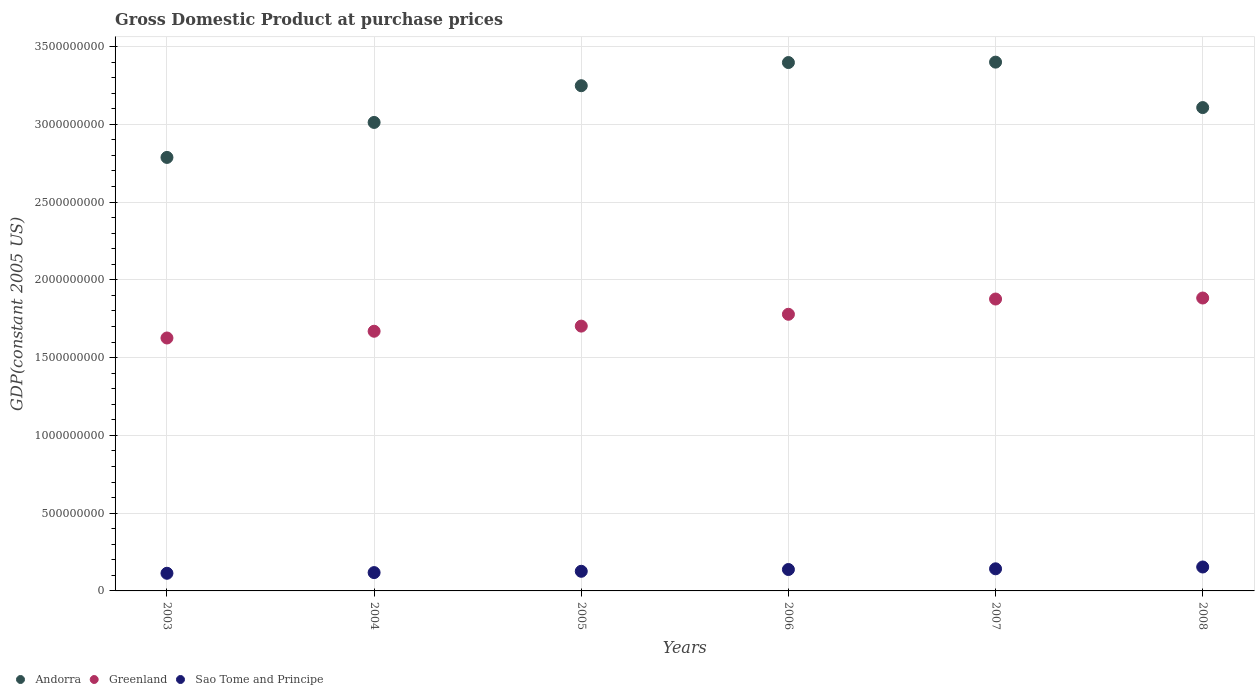How many different coloured dotlines are there?
Make the answer very short. 3. What is the GDP at purchase prices in Greenland in 2006?
Your answer should be compact. 1.78e+09. Across all years, what is the maximum GDP at purchase prices in Greenland?
Make the answer very short. 1.88e+09. Across all years, what is the minimum GDP at purchase prices in Andorra?
Keep it short and to the point. 2.79e+09. In which year was the GDP at purchase prices in Andorra maximum?
Your answer should be compact. 2007. In which year was the GDP at purchase prices in Andorra minimum?
Provide a short and direct response. 2003. What is the total GDP at purchase prices in Greenland in the graph?
Provide a short and direct response. 1.05e+1. What is the difference between the GDP at purchase prices in Greenland in 2003 and that in 2004?
Keep it short and to the point. -4.34e+07. What is the difference between the GDP at purchase prices in Greenland in 2005 and the GDP at purchase prices in Sao Tome and Principe in 2007?
Provide a succinct answer. 1.56e+09. What is the average GDP at purchase prices in Sao Tome and Principe per year?
Your answer should be very brief. 1.32e+08. In the year 2008, what is the difference between the GDP at purchase prices in Greenland and GDP at purchase prices in Sao Tome and Principe?
Give a very brief answer. 1.73e+09. In how many years, is the GDP at purchase prices in Sao Tome and Principe greater than 1000000000 US$?
Ensure brevity in your answer.  0. What is the ratio of the GDP at purchase prices in Greenland in 2006 to that in 2007?
Provide a short and direct response. 0.95. Is the GDP at purchase prices in Sao Tome and Principe in 2004 less than that in 2006?
Your answer should be compact. Yes. Is the difference between the GDP at purchase prices in Greenland in 2004 and 2008 greater than the difference between the GDP at purchase prices in Sao Tome and Principe in 2004 and 2008?
Keep it short and to the point. No. What is the difference between the highest and the second highest GDP at purchase prices in Sao Tome and Principe?
Your answer should be very brief. 1.16e+07. What is the difference between the highest and the lowest GDP at purchase prices in Greenland?
Offer a terse response. 2.57e+08. In how many years, is the GDP at purchase prices in Greenland greater than the average GDP at purchase prices in Greenland taken over all years?
Provide a short and direct response. 3. Is it the case that in every year, the sum of the GDP at purchase prices in Sao Tome and Principe and GDP at purchase prices in Greenland  is greater than the GDP at purchase prices in Andorra?
Your response must be concise. No. How many dotlines are there?
Make the answer very short. 3. How many years are there in the graph?
Your answer should be compact. 6. Are the values on the major ticks of Y-axis written in scientific E-notation?
Make the answer very short. No. Does the graph contain grids?
Provide a short and direct response. Yes. Where does the legend appear in the graph?
Provide a succinct answer. Bottom left. How many legend labels are there?
Make the answer very short. 3. How are the legend labels stacked?
Provide a short and direct response. Horizontal. What is the title of the graph?
Make the answer very short. Gross Domestic Product at purchase prices. Does "Malta" appear as one of the legend labels in the graph?
Offer a very short reply. No. What is the label or title of the Y-axis?
Your answer should be very brief. GDP(constant 2005 US). What is the GDP(constant 2005 US) in Andorra in 2003?
Keep it short and to the point. 2.79e+09. What is the GDP(constant 2005 US) of Greenland in 2003?
Offer a terse response. 1.63e+09. What is the GDP(constant 2005 US) in Sao Tome and Principe in 2003?
Your answer should be compact. 1.13e+08. What is the GDP(constant 2005 US) of Andorra in 2004?
Make the answer very short. 3.01e+09. What is the GDP(constant 2005 US) of Greenland in 2004?
Make the answer very short. 1.67e+09. What is the GDP(constant 2005 US) in Sao Tome and Principe in 2004?
Your answer should be compact. 1.18e+08. What is the GDP(constant 2005 US) in Andorra in 2005?
Keep it short and to the point. 3.25e+09. What is the GDP(constant 2005 US) in Greenland in 2005?
Give a very brief answer. 1.70e+09. What is the GDP(constant 2005 US) in Sao Tome and Principe in 2005?
Keep it short and to the point. 1.26e+08. What is the GDP(constant 2005 US) in Andorra in 2006?
Make the answer very short. 3.40e+09. What is the GDP(constant 2005 US) in Greenland in 2006?
Your response must be concise. 1.78e+09. What is the GDP(constant 2005 US) of Sao Tome and Principe in 2006?
Provide a succinct answer. 1.38e+08. What is the GDP(constant 2005 US) of Andorra in 2007?
Offer a very short reply. 3.40e+09. What is the GDP(constant 2005 US) in Greenland in 2007?
Make the answer very short. 1.88e+09. What is the GDP(constant 2005 US) of Sao Tome and Principe in 2007?
Offer a very short reply. 1.42e+08. What is the GDP(constant 2005 US) of Andorra in 2008?
Offer a very short reply. 3.11e+09. What is the GDP(constant 2005 US) of Greenland in 2008?
Make the answer very short. 1.88e+09. What is the GDP(constant 2005 US) of Sao Tome and Principe in 2008?
Keep it short and to the point. 1.54e+08. Across all years, what is the maximum GDP(constant 2005 US) in Andorra?
Your answer should be very brief. 3.40e+09. Across all years, what is the maximum GDP(constant 2005 US) of Greenland?
Your answer should be very brief. 1.88e+09. Across all years, what is the maximum GDP(constant 2005 US) in Sao Tome and Principe?
Your response must be concise. 1.54e+08. Across all years, what is the minimum GDP(constant 2005 US) in Andorra?
Your response must be concise. 2.79e+09. Across all years, what is the minimum GDP(constant 2005 US) of Greenland?
Offer a very short reply. 1.63e+09. Across all years, what is the minimum GDP(constant 2005 US) of Sao Tome and Principe?
Keep it short and to the point. 1.13e+08. What is the total GDP(constant 2005 US) of Andorra in the graph?
Provide a short and direct response. 1.90e+1. What is the total GDP(constant 2005 US) of Greenland in the graph?
Offer a terse response. 1.05e+1. What is the total GDP(constant 2005 US) of Sao Tome and Principe in the graph?
Keep it short and to the point. 7.91e+08. What is the difference between the GDP(constant 2005 US) in Andorra in 2003 and that in 2004?
Your response must be concise. -2.25e+08. What is the difference between the GDP(constant 2005 US) of Greenland in 2003 and that in 2004?
Offer a terse response. -4.34e+07. What is the difference between the GDP(constant 2005 US) of Sao Tome and Principe in 2003 and that in 2004?
Ensure brevity in your answer.  -4.35e+06. What is the difference between the GDP(constant 2005 US) of Andorra in 2003 and that in 2005?
Keep it short and to the point. -4.61e+08. What is the difference between the GDP(constant 2005 US) in Greenland in 2003 and that in 2005?
Your response must be concise. -7.64e+07. What is the difference between the GDP(constant 2005 US) in Sao Tome and Principe in 2003 and that in 2005?
Offer a terse response. -1.27e+07. What is the difference between the GDP(constant 2005 US) of Andorra in 2003 and that in 2006?
Offer a terse response. -6.10e+08. What is the difference between the GDP(constant 2005 US) in Greenland in 2003 and that in 2006?
Your response must be concise. -1.53e+08. What is the difference between the GDP(constant 2005 US) of Sao Tome and Principe in 2003 and that in 2006?
Ensure brevity in your answer.  -2.42e+07. What is the difference between the GDP(constant 2005 US) in Andorra in 2003 and that in 2007?
Your answer should be very brief. -6.13e+08. What is the difference between the GDP(constant 2005 US) in Greenland in 2003 and that in 2007?
Give a very brief answer. -2.51e+08. What is the difference between the GDP(constant 2005 US) of Sao Tome and Principe in 2003 and that in 2007?
Make the answer very short. -2.87e+07. What is the difference between the GDP(constant 2005 US) of Andorra in 2003 and that in 2008?
Your answer should be very brief. -3.20e+08. What is the difference between the GDP(constant 2005 US) of Greenland in 2003 and that in 2008?
Give a very brief answer. -2.57e+08. What is the difference between the GDP(constant 2005 US) of Sao Tome and Principe in 2003 and that in 2008?
Provide a succinct answer. -4.03e+07. What is the difference between the GDP(constant 2005 US) of Andorra in 2004 and that in 2005?
Make the answer very short. -2.36e+08. What is the difference between the GDP(constant 2005 US) of Greenland in 2004 and that in 2005?
Offer a terse response. -3.30e+07. What is the difference between the GDP(constant 2005 US) in Sao Tome and Principe in 2004 and that in 2005?
Provide a short and direct response. -8.36e+06. What is the difference between the GDP(constant 2005 US) in Andorra in 2004 and that in 2006?
Your answer should be compact. -3.85e+08. What is the difference between the GDP(constant 2005 US) of Greenland in 2004 and that in 2006?
Your response must be concise. -1.09e+08. What is the difference between the GDP(constant 2005 US) of Sao Tome and Principe in 2004 and that in 2006?
Keep it short and to the point. -1.99e+07. What is the difference between the GDP(constant 2005 US) of Andorra in 2004 and that in 2007?
Keep it short and to the point. -3.88e+08. What is the difference between the GDP(constant 2005 US) in Greenland in 2004 and that in 2007?
Provide a succinct answer. -2.07e+08. What is the difference between the GDP(constant 2005 US) of Sao Tome and Principe in 2004 and that in 2007?
Your answer should be compact. -2.43e+07. What is the difference between the GDP(constant 2005 US) in Andorra in 2004 and that in 2008?
Provide a succinct answer. -9.55e+07. What is the difference between the GDP(constant 2005 US) in Greenland in 2004 and that in 2008?
Ensure brevity in your answer.  -2.14e+08. What is the difference between the GDP(constant 2005 US) of Sao Tome and Principe in 2004 and that in 2008?
Offer a terse response. -3.60e+07. What is the difference between the GDP(constant 2005 US) of Andorra in 2005 and that in 2006?
Keep it short and to the point. -1.49e+08. What is the difference between the GDP(constant 2005 US) of Greenland in 2005 and that in 2006?
Offer a terse response. -7.61e+07. What is the difference between the GDP(constant 2005 US) in Sao Tome and Principe in 2005 and that in 2006?
Provide a succinct answer. -1.15e+07. What is the difference between the GDP(constant 2005 US) in Andorra in 2005 and that in 2007?
Provide a short and direct response. -1.52e+08. What is the difference between the GDP(constant 2005 US) of Greenland in 2005 and that in 2007?
Your response must be concise. -1.74e+08. What is the difference between the GDP(constant 2005 US) in Sao Tome and Principe in 2005 and that in 2007?
Your response must be concise. -1.60e+07. What is the difference between the GDP(constant 2005 US) in Andorra in 2005 and that in 2008?
Make the answer very short. 1.41e+08. What is the difference between the GDP(constant 2005 US) in Greenland in 2005 and that in 2008?
Your answer should be very brief. -1.81e+08. What is the difference between the GDP(constant 2005 US) of Sao Tome and Principe in 2005 and that in 2008?
Your answer should be compact. -2.76e+07. What is the difference between the GDP(constant 2005 US) of Andorra in 2006 and that in 2007?
Provide a short and direct response. -2.65e+06. What is the difference between the GDP(constant 2005 US) of Greenland in 2006 and that in 2007?
Give a very brief answer. -9.81e+07. What is the difference between the GDP(constant 2005 US) of Sao Tome and Principe in 2006 and that in 2007?
Offer a terse response. -4.48e+06. What is the difference between the GDP(constant 2005 US) in Andorra in 2006 and that in 2008?
Your answer should be very brief. 2.90e+08. What is the difference between the GDP(constant 2005 US) of Greenland in 2006 and that in 2008?
Offer a terse response. -1.05e+08. What is the difference between the GDP(constant 2005 US) of Sao Tome and Principe in 2006 and that in 2008?
Make the answer very short. -1.61e+07. What is the difference between the GDP(constant 2005 US) of Andorra in 2007 and that in 2008?
Provide a succinct answer. 2.92e+08. What is the difference between the GDP(constant 2005 US) in Greenland in 2007 and that in 2008?
Your answer should be compact. -6.49e+06. What is the difference between the GDP(constant 2005 US) of Sao Tome and Principe in 2007 and that in 2008?
Make the answer very short. -1.16e+07. What is the difference between the GDP(constant 2005 US) of Andorra in 2003 and the GDP(constant 2005 US) of Greenland in 2004?
Your answer should be compact. 1.12e+09. What is the difference between the GDP(constant 2005 US) of Andorra in 2003 and the GDP(constant 2005 US) of Sao Tome and Principe in 2004?
Ensure brevity in your answer.  2.67e+09. What is the difference between the GDP(constant 2005 US) in Greenland in 2003 and the GDP(constant 2005 US) in Sao Tome and Principe in 2004?
Provide a succinct answer. 1.51e+09. What is the difference between the GDP(constant 2005 US) of Andorra in 2003 and the GDP(constant 2005 US) of Greenland in 2005?
Provide a succinct answer. 1.08e+09. What is the difference between the GDP(constant 2005 US) of Andorra in 2003 and the GDP(constant 2005 US) of Sao Tome and Principe in 2005?
Offer a very short reply. 2.66e+09. What is the difference between the GDP(constant 2005 US) of Greenland in 2003 and the GDP(constant 2005 US) of Sao Tome and Principe in 2005?
Give a very brief answer. 1.50e+09. What is the difference between the GDP(constant 2005 US) in Andorra in 2003 and the GDP(constant 2005 US) in Greenland in 2006?
Give a very brief answer. 1.01e+09. What is the difference between the GDP(constant 2005 US) in Andorra in 2003 and the GDP(constant 2005 US) in Sao Tome and Principe in 2006?
Provide a short and direct response. 2.65e+09. What is the difference between the GDP(constant 2005 US) in Greenland in 2003 and the GDP(constant 2005 US) in Sao Tome and Principe in 2006?
Make the answer very short. 1.49e+09. What is the difference between the GDP(constant 2005 US) in Andorra in 2003 and the GDP(constant 2005 US) in Greenland in 2007?
Provide a short and direct response. 9.10e+08. What is the difference between the GDP(constant 2005 US) in Andorra in 2003 and the GDP(constant 2005 US) in Sao Tome and Principe in 2007?
Make the answer very short. 2.64e+09. What is the difference between the GDP(constant 2005 US) in Greenland in 2003 and the GDP(constant 2005 US) in Sao Tome and Principe in 2007?
Your answer should be very brief. 1.48e+09. What is the difference between the GDP(constant 2005 US) in Andorra in 2003 and the GDP(constant 2005 US) in Greenland in 2008?
Offer a terse response. 9.04e+08. What is the difference between the GDP(constant 2005 US) in Andorra in 2003 and the GDP(constant 2005 US) in Sao Tome and Principe in 2008?
Your answer should be very brief. 2.63e+09. What is the difference between the GDP(constant 2005 US) of Greenland in 2003 and the GDP(constant 2005 US) of Sao Tome and Principe in 2008?
Ensure brevity in your answer.  1.47e+09. What is the difference between the GDP(constant 2005 US) of Andorra in 2004 and the GDP(constant 2005 US) of Greenland in 2005?
Give a very brief answer. 1.31e+09. What is the difference between the GDP(constant 2005 US) in Andorra in 2004 and the GDP(constant 2005 US) in Sao Tome and Principe in 2005?
Make the answer very short. 2.89e+09. What is the difference between the GDP(constant 2005 US) of Greenland in 2004 and the GDP(constant 2005 US) of Sao Tome and Principe in 2005?
Give a very brief answer. 1.54e+09. What is the difference between the GDP(constant 2005 US) of Andorra in 2004 and the GDP(constant 2005 US) of Greenland in 2006?
Your answer should be compact. 1.23e+09. What is the difference between the GDP(constant 2005 US) in Andorra in 2004 and the GDP(constant 2005 US) in Sao Tome and Principe in 2006?
Provide a short and direct response. 2.87e+09. What is the difference between the GDP(constant 2005 US) in Greenland in 2004 and the GDP(constant 2005 US) in Sao Tome and Principe in 2006?
Your response must be concise. 1.53e+09. What is the difference between the GDP(constant 2005 US) in Andorra in 2004 and the GDP(constant 2005 US) in Greenland in 2007?
Give a very brief answer. 1.14e+09. What is the difference between the GDP(constant 2005 US) of Andorra in 2004 and the GDP(constant 2005 US) of Sao Tome and Principe in 2007?
Keep it short and to the point. 2.87e+09. What is the difference between the GDP(constant 2005 US) in Greenland in 2004 and the GDP(constant 2005 US) in Sao Tome and Principe in 2007?
Provide a succinct answer. 1.53e+09. What is the difference between the GDP(constant 2005 US) in Andorra in 2004 and the GDP(constant 2005 US) in Greenland in 2008?
Offer a very short reply. 1.13e+09. What is the difference between the GDP(constant 2005 US) in Andorra in 2004 and the GDP(constant 2005 US) in Sao Tome and Principe in 2008?
Provide a succinct answer. 2.86e+09. What is the difference between the GDP(constant 2005 US) of Greenland in 2004 and the GDP(constant 2005 US) of Sao Tome and Principe in 2008?
Your response must be concise. 1.52e+09. What is the difference between the GDP(constant 2005 US) of Andorra in 2005 and the GDP(constant 2005 US) of Greenland in 2006?
Make the answer very short. 1.47e+09. What is the difference between the GDP(constant 2005 US) in Andorra in 2005 and the GDP(constant 2005 US) in Sao Tome and Principe in 2006?
Provide a succinct answer. 3.11e+09. What is the difference between the GDP(constant 2005 US) in Greenland in 2005 and the GDP(constant 2005 US) in Sao Tome and Principe in 2006?
Make the answer very short. 1.56e+09. What is the difference between the GDP(constant 2005 US) in Andorra in 2005 and the GDP(constant 2005 US) in Greenland in 2007?
Offer a very short reply. 1.37e+09. What is the difference between the GDP(constant 2005 US) of Andorra in 2005 and the GDP(constant 2005 US) of Sao Tome and Principe in 2007?
Make the answer very short. 3.11e+09. What is the difference between the GDP(constant 2005 US) of Greenland in 2005 and the GDP(constant 2005 US) of Sao Tome and Principe in 2007?
Your answer should be very brief. 1.56e+09. What is the difference between the GDP(constant 2005 US) in Andorra in 2005 and the GDP(constant 2005 US) in Greenland in 2008?
Ensure brevity in your answer.  1.36e+09. What is the difference between the GDP(constant 2005 US) of Andorra in 2005 and the GDP(constant 2005 US) of Sao Tome and Principe in 2008?
Provide a succinct answer. 3.09e+09. What is the difference between the GDP(constant 2005 US) in Greenland in 2005 and the GDP(constant 2005 US) in Sao Tome and Principe in 2008?
Give a very brief answer. 1.55e+09. What is the difference between the GDP(constant 2005 US) of Andorra in 2006 and the GDP(constant 2005 US) of Greenland in 2007?
Offer a very short reply. 1.52e+09. What is the difference between the GDP(constant 2005 US) of Andorra in 2006 and the GDP(constant 2005 US) of Sao Tome and Principe in 2007?
Your answer should be compact. 3.25e+09. What is the difference between the GDP(constant 2005 US) of Greenland in 2006 and the GDP(constant 2005 US) of Sao Tome and Principe in 2007?
Make the answer very short. 1.64e+09. What is the difference between the GDP(constant 2005 US) of Andorra in 2006 and the GDP(constant 2005 US) of Greenland in 2008?
Offer a very short reply. 1.51e+09. What is the difference between the GDP(constant 2005 US) in Andorra in 2006 and the GDP(constant 2005 US) in Sao Tome and Principe in 2008?
Your answer should be compact. 3.24e+09. What is the difference between the GDP(constant 2005 US) of Greenland in 2006 and the GDP(constant 2005 US) of Sao Tome and Principe in 2008?
Your answer should be compact. 1.62e+09. What is the difference between the GDP(constant 2005 US) in Andorra in 2007 and the GDP(constant 2005 US) in Greenland in 2008?
Keep it short and to the point. 1.52e+09. What is the difference between the GDP(constant 2005 US) of Andorra in 2007 and the GDP(constant 2005 US) of Sao Tome and Principe in 2008?
Offer a terse response. 3.25e+09. What is the difference between the GDP(constant 2005 US) of Greenland in 2007 and the GDP(constant 2005 US) of Sao Tome and Principe in 2008?
Keep it short and to the point. 1.72e+09. What is the average GDP(constant 2005 US) in Andorra per year?
Your response must be concise. 3.16e+09. What is the average GDP(constant 2005 US) in Greenland per year?
Offer a terse response. 1.76e+09. What is the average GDP(constant 2005 US) of Sao Tome and Principe per year?
Provide a short and direct response. 1.32e+08. In the year 2003, what is the difference between the GDP(constant 2005 US) of Andorra and GDP(constant 2005 US) of Greenland?
Make the answer very short. 1.16e+09. In the year 2003, what is the difference between the GDP(constant 2005 US) of Andorra and GDP(constant 2005 US) of Sao Tome and Principe?
Your response must be concise. 2.67e+09. In the year 2003, what is the difference between the GDP(constant 2005 US) of Greenland and GDP(constant 2005 US) of Sao Tome and Principe?
Provide a short and direct response. 1.51e+09. In the year 2004, what is the difference between the GDP(constant 2005 US) in Andorra and GDP(constant 2005 US) in Greenland?
Your response must be concise. 1.34e+09. In the year 2004, what is the difference between the GDP(constant 2005 US) in Andorra and GDP(constant 2005 US) in Sao Tome and Principe?
Your answer should be compact. 2.89e+09. In the year 2004, what is the difference between the GDP(constant 2005 US) of Greenland and GDP(constant 2005 US) of Sao Tome and Principe?
Ensure brevity in your answer.  1.55e+09. In the year 2005, what is the difference between the GDP(constant 2005 US) of Andorra and GDP(constant 2005 US) of Greenland?
Provide a succinct answer. 1.55e+09. In the year 2005, what is the difference between the GDP(constant 2005 US) in Andorra and GDP(constant 2005 US) in Sao Tome and Principe?
Offer a very short reply. 3.12e+09. In the year 2005, what is the difference between the GDP(constant 2005 US) in Greenland and GDP(constant 2005 US) in Sao Tome and Principe?
Your response must be concise. 1.58e+09. In the year 2006, what is the difference between the GDP(constant 2005 US) in Andorra and GDP(constant 2005 US) in Greenland?
Provide a short and direct response. 1.62e+09. In the year 2006, what is the difference between the GDP(constant 2005 US) of Andorra and GDP(constant 2005 US) of Sao Tome and Principe?
Keep it short and to the point. 3.26e+09. In the year 2006, what is the difference between the GDP(constant 2005 US) of Greenland and GDP(constant 2005 US) of Sao Tome and Principe?
Offer a very short reply. 1.64e+09. In the year 2007, what is the difference between the GDP(constant 2005 US) of Andorra and GDP(constant 2005 US) of Greenland?
Your answer should be very brief. 1.52e+09. In the year 2007, what is the difference between the GDP(constant 2005 US) of Andorra and GDP(constant 2005 US) of Sao Tome and Principe?
Give a very brief answer. 3.26e+09. In the year 2007, what is the difference between the GDP(constant 2005 US) of Greenland and GDP(constant 2005 US) of Sao Tome and Principe?
Your answer should be compact. 1.73e+09. In the year 2008, what is the difference between the GDP(constant 2005 US) in Andorra and GDP(constant 2005 US) in Greenland?
Offer a very short reply. 1.22e+09. In the year 2008, what is the difference between the GDP(constant 2005 US) of Andorra and GDP(constant 2005 US) of Sao Tome and Principe?
Your answer should be compact. 2.95e+09. In the year 2008, what is the difference between the GDP(constant 2005 US) of Greenland and GDP(constant 2005 US) of Sao Tome and Principe?
Your answer should be very brief. 1.73e+09. What is the ratio of the GDP(constant 2005 US) of Andorra in 2003 to that in 2004?
Your response must be concise. 0.93. What is the ratio of the GDP(constant 2005 US) of Sao Tome and Principe in 2003 to that in 2004?
Ensure brevity in your answer.  0.96. What is the ratio of the GDP(constant 2005 US) in Andorra in 2003 to that in 2005?
Make the answer very short. 0.86. What is the ratio of the GDP(constant 2005 US) in Greenland in 2003 to that in 2005?
Your response must be concise. 0.96. What is the ratio of the GDP(constant 2005 US) in Sao Tome and Principe in 2003 to that in 2005?
Your answer should be compact. 0.9. What is the ratio of the GDP(constant 2005 US) in Andorra in 2003 to that in 2006?
Offer a terse response. 0.82. What is the ratio of the GDP(constant 2005 US) of Greenland in 2003 to that in 2006?
Your answer should be compact. 0.91. What is the ratio of the GDP(constant 2005 US) in Sao Tome and Principe in 2003 to that in 2006?
Offer a terse response. 0.82. What is the ratio of the GDP(constant 2005 US) of Andorra in 2003 to that in 2007?
Offer a terse response. 0.82. What is the ratio of the GDP(constant 2005 US) of Greenland in 2003 to that in 2007?
Offer a terse response. 0.87. What is the ratio of the GDP(constant 2005 US) of Sao Tome and Principe in 2003 to that in 2007?
Make the answer very short. 0.8. What is the ratio of the GDP(constant 2005 US) of Andorra in 2003 to that in 2008?
Provide a succinct answer. 0.9. What is the ratio of the GDP(constant 2005 US) in Greenland in 2003 to that in 2008?
Your answer should be compact. 0.86. What is the ratio of the GDP(constant 2005 US) of Sao Tome and Principe in 2003 to that in 2008?
Make the answer very short. 0.74. What is the ratio of the GDP(constant 2005 US) of Andorra in 2004 to that in 2005?
Provide a short and direct response. 0.93. What is the ratio of the GDP(constant 2005 US) in Greenland in 2004 to that in 2005?
Offer a very short reply. 0.98. What is the ratio of the GDP(constant 2005 US) of Sao Tome and Principe in 2004 to that in 2005?
Provide a short and direct response. 0.93. What is the ratio of the GDP(constant 2005 US) in Andorra in 2004 to that in 2006?
Ensure brevity in your answer.  0.89. What is the ratio of the GDP(constant 2005 US) of Greenland in 2004 to that in 2006?
Your answer should be compact. 0.94. What is the ratio of the GDP(constant 2005 US) of Sao Tome and Principe in 2004 to that in 2006?
Ensure brevity in your answer.  0.86. What is the ratio of the GDP(constant 2005 US) of Andorra in 2004 to that in 2007?
Provide a succinct answer. 0.89. What is the ratio of the GDP(constant 2005 US) in Greenland in 2004 to that in 2007?
Your response must be concise. 0.89. What is the ratio of the GDP(constant 2005 US) of Sao Tome and Principe in 2004 to that in 2007?
Your answer should be compact. 0.83. What is the ratio of the GDP(constant 2005 US) in Andorra in 2004 to that in 2008?
Offer a terse response. 0.97. What is the ratio of the GDP(constant 2005 US) of Greenland in 2004 to that in 2008?
Make the answer very short. 0.89. What is the ratio of the GDP(constant 2005 US) of Sao Tome and Principe in 2004 to that in 2008?
Provide a succinct answer. 0.77. What is the ratio of the GDP(constant 2005 US) in Andorra in 2005 to that in 2006?
Your answer should be compact. 0.96. What is the ratio of the GDP(constant 2005 US) of Greenland in 2005 to that in 2006?
Provide a succinct answer. 0.96. What is the ratio of the GDP(constant 2005 US) in Sao Tome and Principe in 2005 to that in 2006?
Your response must be concise. 0.92. What is the ratio of the GDP(constant 2005 US) in Andorra in 2005 to that in 2007?
Your response must be concise. 0.96. What is the ratio of the GDP(constant 2005 US) of Greenland in 2005 to that in 2007?
Make the answer very short. 0.91. What is the ratio of the GDP(constant 2005 US) in Sao Tome and Principe in 2005 to that in 2007?
Offer a terse response. 0.89. What is the ratio of the GDP(constant 2005 US) of Andorra in 2005 to that in 2008?
Ensure brevity in your answer.  1.05. What is the ratio of the GDP(constant 2005 US) of Greenland in 2005 to that in 2008?
Offer a terse response. 0.9. What is the ratio of the GDP(constant 2005 US) of Sao Tome and Principe in 2005 to that in 2008?
Make the answer very short. 0.82. What is the ratio of the GDP(constant 2005 US) in Greenland in 2006 to that in 2007?
Offer a very short reply. 0.95. What is the ratio of the GDP(constant 2005 US) of Sao Tome and Principe in 2006 to that in 2007?
Ensure brevity in your answer.  0.97. What is the ratio of the GDP(constant 2005 US) in Andorra in 2006 to that in 2008?
Offer a terse response. 1.09. What is the ratio of the GDP(constant 2005 US) in Greenland in 2006 to that in 2008?
Ensure brevity in your answer.  0.94. What is the ratio of the GDP(constant 2005 US) of Sao Tome and Principe in 2006 to that in 2008?
Your response must be concise. 0.9. What is the ratio of the GDP(constant 2005 US) of Andorra in 2007 to that in 2008?
Offer a very short reply. 1.09. What is the ratio of the GDP(constant 2005 US) in Sao Tome and Principe in 2007 to that in 2008?
Ensure brevity in your answer.  0.92. What is the difference between the highest and the second highest GDP(constant 2005 US) of Andorra?
Your answer should be compact. 2.65e+06. What is the difference between the highest and the second highest GDP(constant 2005 US) of Greenland?
Your response must be concise. 6.49e+06. What is the difference between the highest and the second highest GDP(constant 2005 US) in Sao Tome and Principe?
Make the answer very short. 1.16e+07. What is the difference between the highest and the lowest GDP(constant 2005 US) of Andorra?
Your response must be concise. 6.13e+08. What is the difference between the highest and the lowest GDP(constant 2005 US) of Greenland?
Provide a short and direct response. 2.57e+08. What is the difference between the highest and the lowest GDP(constant 2005 US) in Sao Tome and Principe?
Offer a very short reply. 4.03e+07. 